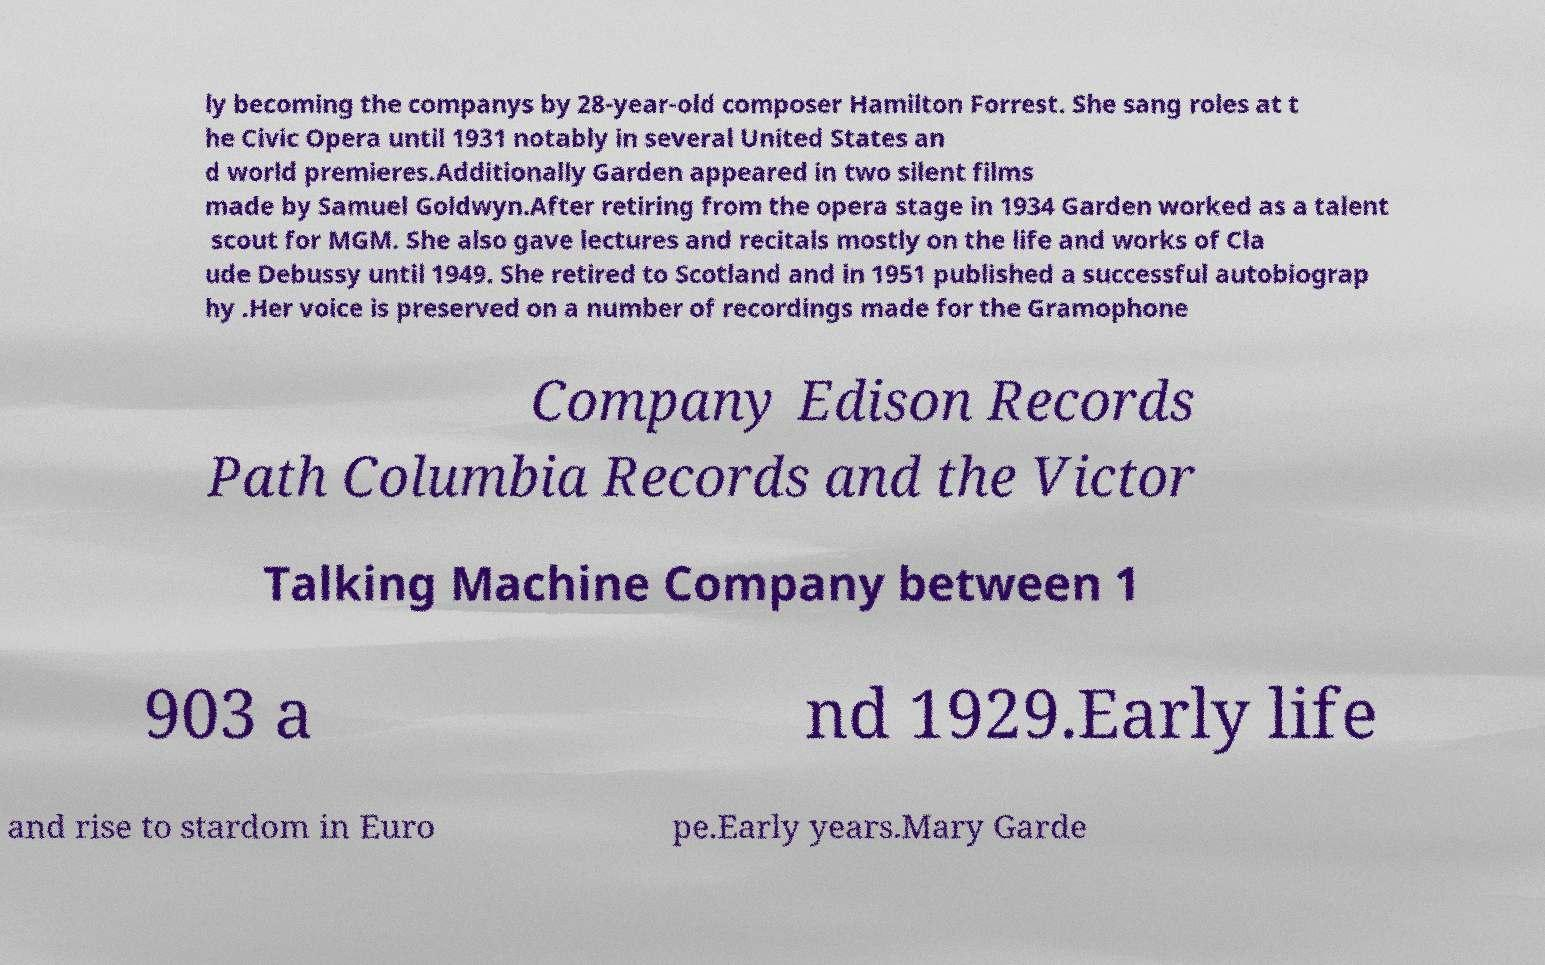There's text embedded in this image that I need extracted. Can you transcribe it verbatim? ly becoming the companys by 28-year-old composer Hamilton Forrest. She sang roles at t he Civic Opera until 1931 notably in several United States an d world premieres.Additionally Garden appeared in two silent films made by Samuel Goldwyn.After retiring from the opera stage in 1934 Garden worked as a talent scout for MGM. She also gave lectures and recitals mostly on the life and works of Cla ude Debussy until 1949. She retired to Scotland and in 1951 published a successful autobiograp hy .Her voice is preserved on a number of recordings made for the Gramophone Company Edison Records Path Columbia Records and the Victor Talking Machine Company between 1 903 a nd 1929.Early life and rise to stardom in Euro pe.Early years.Mary Garde 